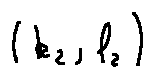Convert formula to latex. <formula><loc_0><loc_0><loc_500><loc_500>( k _ { 2 } , l _ { 2 } )</formula> 